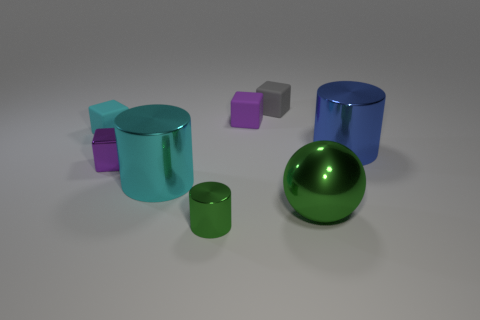Subtract all yellow cylinders. How many purple blocks are left? 2 Add 1 big rubber things. How many objects exist? 9 Subtract all tiny cyan cubes. How many cubes are left? 3 Subtract all gray cubes. How many cubes are left? 3 Subtract all red cubes. Subtract all blue cylinders. How many cubes are left? 4 Subtract all balls. How many objects are left? 7 Add 5 small gray matte objects. How many small gray matte objects exist? 6 Subtract 0 brown cylinders. How many objects are left? 8 Subtract all large objects. Subtract all balls. How many objects are left? 4 Add 2 green shiny things. How many green shiny things are left? 4 